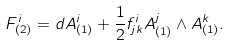<formula> <loc_0><loc_0><loc_500><loc_500>F _ { ( 2 ) } ^ { i } = d A _ { ( 1 ) } ^ { i } + \frac { 1 } { 2 } f _ { j k } ^ { i } A _ { ( 1 ) } ^ { j } \wedge A _ { ( 1 ) } ^ { k } .</formula> 